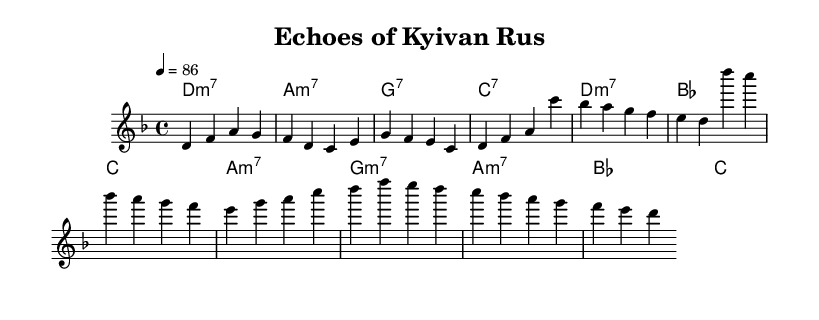What is the key signature of this music? The key signature indicates D minor, which has one flat (B flat). This is determined by looking at the key signature shown at the beginning of the staff.
Answer: D minor What is the time signature of this piece? The time signature is found near the beginning of the score. It shows a '4/4' marking, meaning there are four beats in a measure and a quarter note receives one beat.
Answer: 4/4 What is the tempo marking of the piece? The tempo is specified as '4 = 86', which means there are 86 beats per minute. It's indicated above the staff in the tempo definition section.
Answer: 86 How many measures are in the verse section? To determine the number of measures in the verse, we count the distinct groups of notes in the melody section labeled 'Verse'. There are four distinct groups, separated by vertical lines.
Answer: 4 What is the harmonic structure (chord progression) used in the chorus? The chord progression is derived from the harmonies section labeled 'Chorus'. By identifying the chords listed, the structure is determined to be D minor 7, A minor 7, G7, C7.
Answer: D minor 7, A minor 7, G7, C7 Does this composition feature a typical R&B influence? Yes, the use of seventh chords and syncopated rhythms, along with emotional lyrical themes, align with the characteristics of Rhythm and Blues music. This can be identified in both the chord choices and the melodic style.
Answer: Yes What emotional tone does the melody evoke? The overall melodic contour in D minor, with its rise and fall, creates a reflective and somber tone, effectively reflecting on history and traditions which is an emotional signature of neo-soul.
Answer: Reflective 